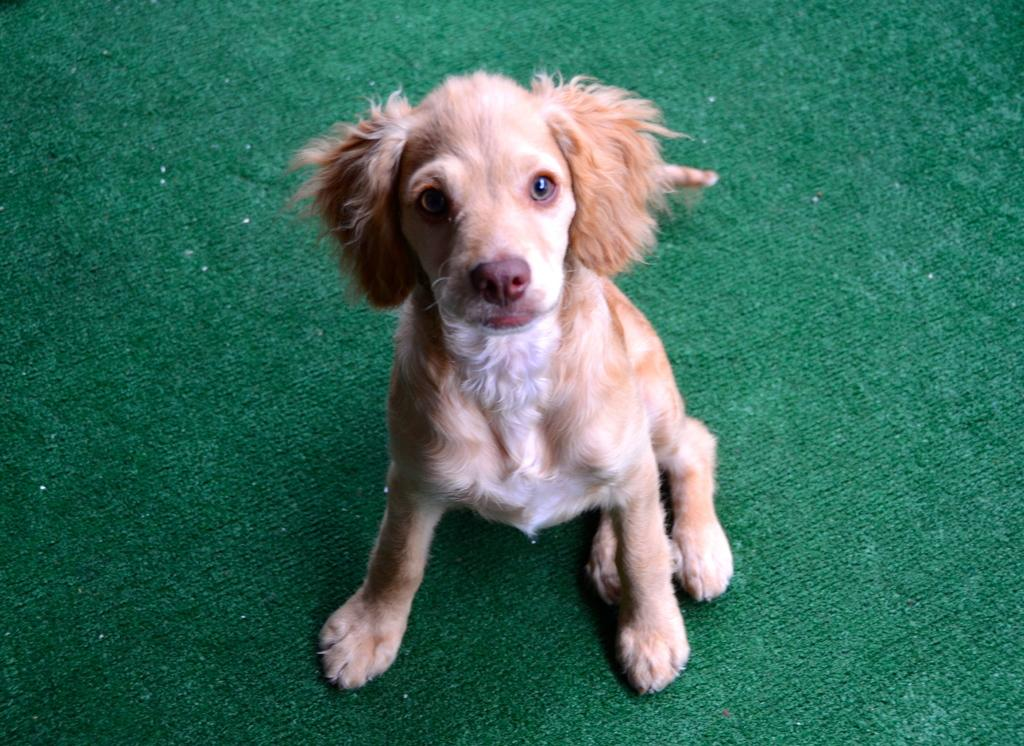What type of animal is in the picture? There is a small brown dog in the picture. What is the dog sitting on? The dog is sitting on a green carpet. What is the dog's behavior in the picture? The dog is looking at the camera. What type of gate can be seen in the picture? There is no gate present in the picture; it features a small brown dog sitting on a green carpet and looking at the camera. 